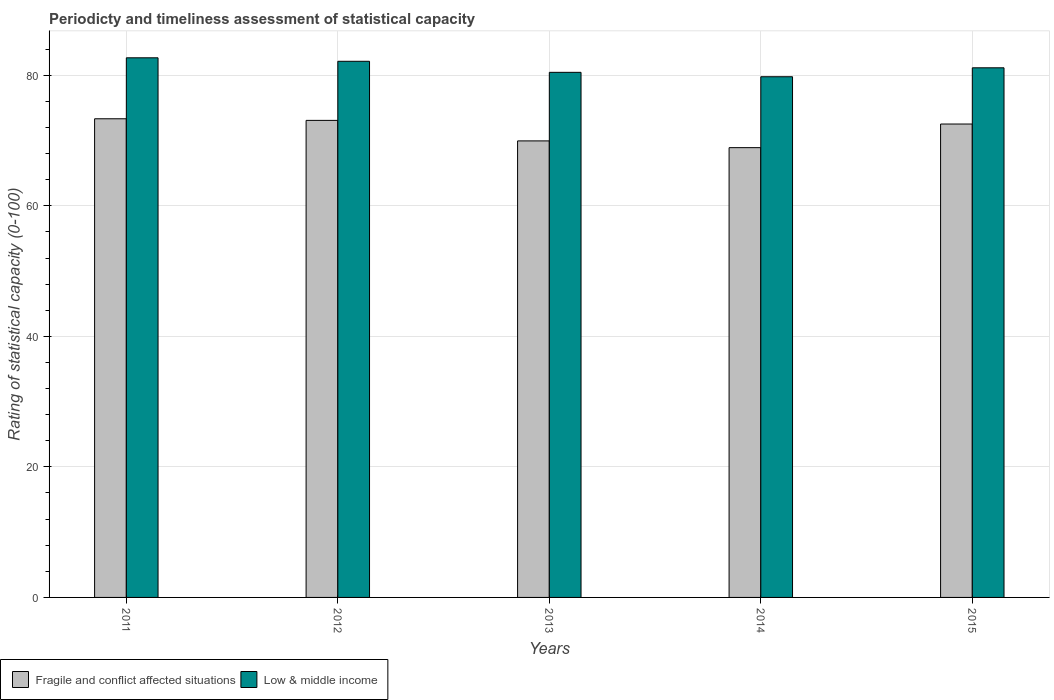How many groups of bars are there?
Give a very brief answer. 5. Are the number of bars on each tick of the X-axis equal?
Offer a very short reply. Yes. How many bars are there on the 5th tick from the left?
Provide a succinct answer. 2. In how many cases, is the number of bars for a given year not equal to the number of legend labels?
Make the answer very short. 0. What is the rating of statistical capacity in Low & middle income in 2012?
Provide a short and direct response. 82.14. Across all years, what is the maximum rating of statistical capacity in Low & middle income?
Your answer should be very brief. 82.67. Across all years, what is the minimum rating of statistical capacity in Low & middle income?
Provide a succinct answer. 79.77. What is the total rating of statistical capacity in Low & middle income in the graph?
Make the answer very short. 406.17. What is the difference between the rating of statistical capacity in Low & middle income in 2011 and that in 2012?
Give a very brief answer. 0.53. What is the difference between the rating of statistical capacity in Fragile and conflict affected situations in 2012 and the rating of statistical capacity in Low & middle income in 2013?
Offer a terse response. -7.36. What is the average rating of statistical capacity in Low & middle income per year?
Give a very brief answer. 81.23. In the year 2013, what is the difference between the rating of statistical capacity in Fragile and conflict affected situations and rating of statistical capacity in Low & middle income?
Make the answer very short. -10.51. In how many years, is the rating of statistical capacity in Low & middle income greater than 8?
Your answer should be very brief. 5. What is the ratio of the rating of statistical capacity in Fragile and conflict affected situations in 2011 to that in 2015?
Offer a very short reply. 1.01. Is the difference between the rating of statistical capacity in Fragile and conflict affected situations in 2013 and 2014 greater than the difference between the rating of statistical capacity in Low & middle income in 2013 and 2014?
Your answer should be very brief. Yes. What is the difference between the highest and the second highest rating of statistical capacity in Fragile and conflict affected situations?
Ensure brevity in your answer.  0.25. What is the difference between the highest and the lowest rating of statistical capacity in Fragile and conflict affected situations?
Keep it short and to the point. 4.43. In how many years, is the rating of statistical capacity in Fragile and conflict affected situations greater than the average rating of statistical capacity in Fragile and conflict affected situations taken over all years?
Offer a terse response. 3. What does the 1st bar from the left in 2012 represents?
Offer a terse response. Fragile and conflict affected situations. Does the graph contain any zero values?
Your response must be concise. No. Does the graph contain grids?
Your answer should be compact. Yes. How many legend labels are there?
Your response must be concise. 2. What is the title of the graph?
Offer a terse response. Periodicty and timeliness assessment of statistical capacity. What is the label or title of the Y-axis?
Your answer should be compact. Rating of statistical capacity (0-100). What is the Rating of statistical capacity (0-100) in Fragile and conflict affected situations in 2011?
Offer a terse response. 73.33. What is the Rating of statistical capacity (0-100) of Low & middle income in 2011?
Provide a short and direct response. 82.67. What is the Rating of statistical capacity (0-100) of Fragile and conflict affected situations in 2012?
Provide a succinct answer. 73.09. What is the Rating of statistical capacity (0-100) of Low & middle income in 2012?
Provide a succinct answer. 82.14. What is the Rating of statistical capacity (0-100) of Fragile and conflict affected situations in 2013?
Make the answer very short. 69.94. What is the Rating of statistical capacity (0-100) of Low & middle income in 2013?
Ensure brevity in your answer.  80.45. What is the Rating of statistical capacity (0-100) in Fragile and conflict affected situations in 2014?
Offer a very short reply. 68.91. What is the Rating of statistical capacity (0-100) in Low & middle income in 2014?
Make the answer very short. 79.77. What is the Rating of statistical capacity (0-100) in Fragile and conflict affected situations in 2015?
Offer a very short reply. 72.53. What is the Rating of statistical capacity (0-100) in Low & middle income in 2015?
Your response must be concise. 81.14. Across all years, what is the maximum Rating of statistical capacity (0-100) of Fragile and conflict affected situations?
Offer a very short reply. 73.33. Across all years, what is the maximum Rating of statistical capacity (0-100) of Low & middle income?
Ensure brevity in your answer.  82.67. Across all years, what is the minimum Rating of statistical capacity (0-100) in Fragile and conflict affected situations?
Give a very brief answer. 68.91. Across all years, what is the minimum Rating of statistical capacity (0-100) of Low & middle income?
Provide a short and direct response. 79.77. What is the total Rating of statistical capacity (0-100) in Fragile and conflict affected situations in the graph?
Ensure brevity in your answer.  357.8. What is the total Rating of statistical capacity (0-100) of Low & middle income in the graph?
Offer a very short reply. 406.17. What is the difference between the Rating of statistical capacity (0-100) of Fragile and conflict affected situations in 2011 and that in 2012?
Your answer should be compact. 0.25. What is the difference between the Rating of statistical capacity (0-100) in Low & middle income in 2011 and that in 2012?
Give a very brief answer. 0.53. What is the difference between the Rating of statistical capacity (0-100) in Fragile and conflict affected situations in 2011 and that in 2013?
Offer a very short reply. 3.39. What is the difference between the Rating of statistical capacity (0-100) of Low & middle income in 2011 and that in 2013?
Ensure brevity in your answer.  2.23. What is the difference between the Rating of statistical capacity (0-100) in Fragile and conflict affected situations in 2011 and that in 2014?
Ensure brevity in your answer.  4.43. What is the difference between the Rating of statistical capacity (0-100) of Low & middle income in 2011 and that in 2014?
Keep it short and to the point. 2.9. What is the difference between the Rating of statistical capacity (0-100) in Fragile and conflict affected situations in 2011 and that in 2015?
Offer a terse response. 0.8. What is the difference between the Rating of statistical capacity (0-100) in Low & middle income in 2011 and that in 2015?
Provide a short and direct response. 1.53. What is the difference between the Rating of statistical capacity (0-100) in Fragile and conflict affected situations in 2012 and that in 2013?
Your response must be concise. 3.14. What is the difference between the Rating of statistical capacity (0-100) of Low & middle income in 2012 and that in 2013?
Your response must be concise. 1.69. What is the difference between the Rating of statistical capacity (0-100) of Fragile and conflict affected situations in 2012 and that in 2014?
Offer a terse response. 4.18. What is the difference between the Rating of statistical capacity (0-100) in Low & middle income in 2012 and that in 2014?
Your answer should be very brief. 2.37. What is the difference between the Rating of statistical capacity (0-100) in Fragile and conflict affected situations in 2012 and that in 2015?
Keep it short and to the point. 0.56. What is the difference between the Rating of statistical capacity (0-100) of Low & middle income in 2012 and that in 2015?
Give a very brief answer. 1. What is the difference between the Rating of statistical capacity (0-100) of Fragile and conflict affected situations in 2013 and that in 2014?
Keep it short and to the point. 1.03. What is the difference between the Rating of statistical capacity (0-100) of Low & middle income in 2013 and that in 2014?
Keep it short and to the point. 0.68. What is the difference between the Rating of statistical capacity (0-100) in Fragile and conflict affected situations in 2013 and that in 2015?
Your answer should be very brief. -2.59. What is the difference between the Rating of statistical capacity (0-100) in Low & middle income in 2013 and that in 2015?
Offer a terse response. -0.69. What is the difference between the Rating of statistical capacity (0-100) of Fragile and conflict affected situations in 2014 and that in 2015?
Offer a very short reply. -3.62. What is the difference between the Rating of statistical capacity (0-100) in Low & middle income in 2014 and that in 2015?
Make the answer very short. -1.37. What is the difference between the Rating of statistical capacity (0-100) in Fragile and conflict affected situations in 2011 and the Rating of statistical capacity (0-100) in Low & middle income in 2012?
Offer a terse response. -8.8. What is the difference between the Rating of statistical capacity (0-100) in Fragile and conflict affected situations in 2011 and the Rating of statistical capacity (0-100) in Low & middle income in 2013?
Your answer should be very brief. -7.11. What is the difference between the Rating of statistical capacity (0-100) in Fragile and conflict affected situations in 2011 and the Rating of statistical capacity (0-100) in Low & middle income in 2014?
Give a very brief answer. -6.44. What is the difference between the Rating of statistical capacity (0-100) in Fragile and conflict affected situations in 2011 and the Rating of statistical capacity (0-100) in Low & middle income in 2015?
Give a very brief answer. -7.81. What is the difference between the Rating of statistical capacity (0-100) of Fragile and conflict affected situations in 2012 and the Rating of statistical capacity (0-100) of Low & middle income in 2013?
Offer a very short reply. -7.36. What is the difference between the Rating of statistical capacity (0-100) of Fragile and conflict affected situations in 2012 and the Rating of statistical capacity (0-100) of Low & middle income in 2014?
Ensure brevity in your answer.  -6.69. What is the difference between the Rating of statistical capacity (0-100) of Fragile and conflict affected situations in 2012 and the Rating of statistical capacity (0-100) of Low & middle income in 2015?
Your response must be concise. -8.06. What is the difference between the Rating of statistical capacity (0-100) in Fragile and conflict affected situations in 2013 and the Rating of statistical capacity (0-100) in Low & middle income in 2014?
Offer a terse response. -9.83. What is the difference between the Rating of statistical capacity (0-100) in Fragile and conflict affected situations in 2013 and the Rating of statistical capacity (0-100) in Low & middle income in 2015?
Make the answer very short. -11.2. What is the difference between the Rating of statistical capacity (0-100) in Fragile and conflict affected situations in 2014 and the Rating of statistical capacity (0-100) in Low & middle income in 2015?
Provide a succinct answer. -12.23. What is the average Rating of statistical capacity (0-100) in Fragile and conflict affected situations per year?
Give a very brief answer. 71.56. What is the average Rating of statistical capacity (0-100) of Low & middle income per year?
Your response must be concise. 81.23. In the year 2011, what is the difference between the Rating of statistical capacity (0-100) in Fragile and conflict affected situations and Rating of statistical capacity (0-100) in Low & middle income?
Your response must be concise. -9.34. In the year 2012, what is the difference between the Rating of statistical capacity (0-100) of Fragile and conflict affected situations and Rating of statistical capacity (0-100) of Low & middle income?
Ensure brevity in your answer.  -9.05. In the year 2013, what is the difference between the Rating of statistical capacity (0-100) in Fragile and conflict affected situations and Rating of statistical capacity (0-100) in Low & middle income?
Make the answer very short. -10.51. In the year 2014, what is the difference between the Rating of statistical capacity (0-100) in Fragile and conflict affected situations and Rating of statistical capacity (0-100) in Low & middle income?
Provide a succinct answer. -10.86. In the year 2015, what is the difference between the Rating of statistical capacity (0-100) in Fragile and conflict affected situations and Rating of statistical capacity (0-100) in Low & middle income?
Your response must be concise. -8.61. What is the ratio of the Rating of statistical capacity (0-100) in Low & middle income in 2011 to that in 2012?
Keep it short and to the point. 1.01. What is the ratio of the Rating of statistical capacity (0-100) of Fragile and conflict affected situations in 2011 to that in 2013?
Provide a short and direct response. 1.05. What is the ratio of the Rating of statistical capacity (0-100) of Low & middle income in 2011 to that in 2013?
Offer a very short reply. 1.03. What is the ratio of the Rating of statistical capacity (0-100) in Fragile and conflict affected situations in 2011 to that in 2014?
Give a very brief answer. 1.06. What is the ratio of the Rating of statistical capacity (0-100) in Low & middle income in 2011 to that in 2014?
Offer a terse response. 1.04. What is the ratio of the Rating of statistical capacity (0-100) of Fragile and conflict affected situations in 2011 to that in 2015?
Ensure brevity in your answer.  1.01. What is the ratio of the Rating of statistical capacity (0-100) of Low & middle income in 2011 to that in 2015?
Make the answer very short. 1.02. What is the ratio of the Rating of statistical capacity (0-100) in Fragile and conflict affected situations in 2012 to that in 2013?
Keep it short and to the point. 1.04. What is the ratio of the Rating of statistical capacity (0-100) of Low & middle income in 2012 to that in 2013?
Give a very brief answer. 1.02. What is the ratio of the Rating of statistical capacity (0-100) in Fragile and conflict affected situations in 2012 to that in 2014?
Give a very brief answer. 1.06. What is the ratio of the Rating of statistical capacity (0-100) of Low & middle income in 2012 to that in 2014?
Offer a very short reply. 1.03. What is the ratio of the Rating of statistical capacity (0-100) in Fragile and conflict affected situations in 2012 to that in 2015?
Give a very brief answer. 1.01. What is the ratio of the Rating of statistical capacity (0-100) of Low & middle income in 2012 to that in 2015?
Your answer should be compact. 1.01. What is the ratio of the Rating of statistical capacity (0-100) in Fragile and conflict affected situations in 2013 to that in 2014?
Your answer should be compact. 1.01. What is the ratio of the Rating of statistical capacity (0-100) in Low & middle income in 2013 to that in 2014?
Make the answer very short. 1.01. What is the ratio of the Rating of statistical capacity (0-100) in Fragile and conflict affected situations in 2014 to that in 2015?
Give a very brief answer. 0.95. What is the ratio of the Rating of statistical capacity (0-100) of Low & middle income in 2014 to that in 2015?
Offer a very short reply. 0.98. What is the difference between the highest and the second highest Rating of statistical capacity (0-100) in Fragile and conflict affected situations?
Offer a very short reply. 0.25. What is the difference between the highest and the second highest Rating of statistical capacity (0-100) of Low & middle income?
Offer a terse response. 0.53. What is the difference between the highest and the lowest Rating of statistical capacity (0-100) in Fragile and conflict affected situations?
Give a very brief answer. 4.43. What is the difference between the highest and the lowest Rating of statistical capacity (0-100) of Low & middle income?
Make the answer very short. 2.9. 